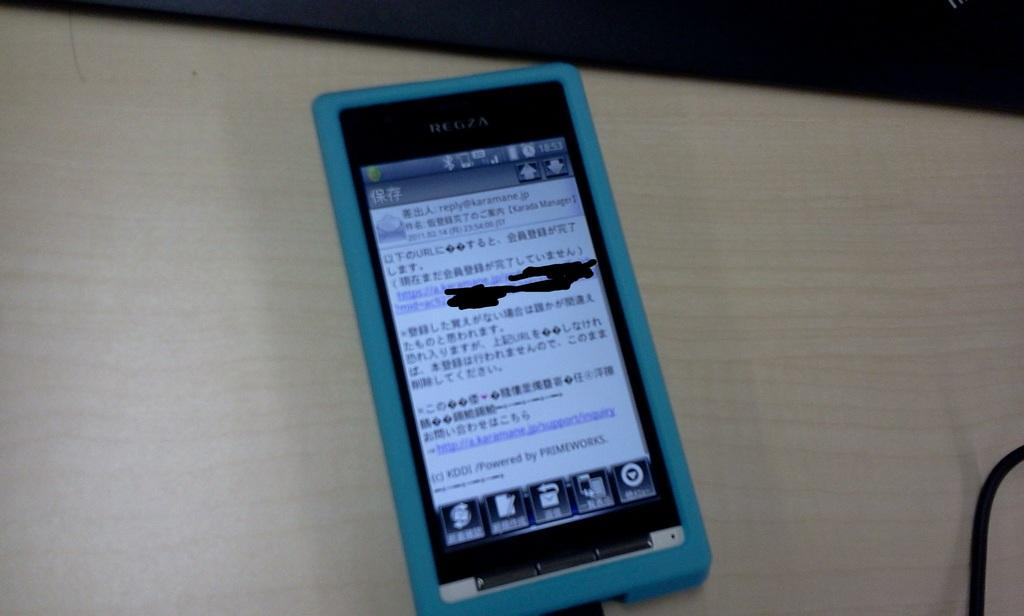<image>
Summarize the visual content of the image. A phone sits with foreign language but the word manager typed on the top right. 